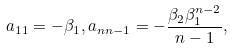Convert formula to latex. <formula><loc_0><loc_0><loc_500><loc_500>a _ { 1 1 } = - \beta _ { 1 } , a _ { n n - 1 } = - \frac { \beta _ { 2 } \beta _ { 1 } ^ { n - 2 } } { n - 1 } ,</formula> 